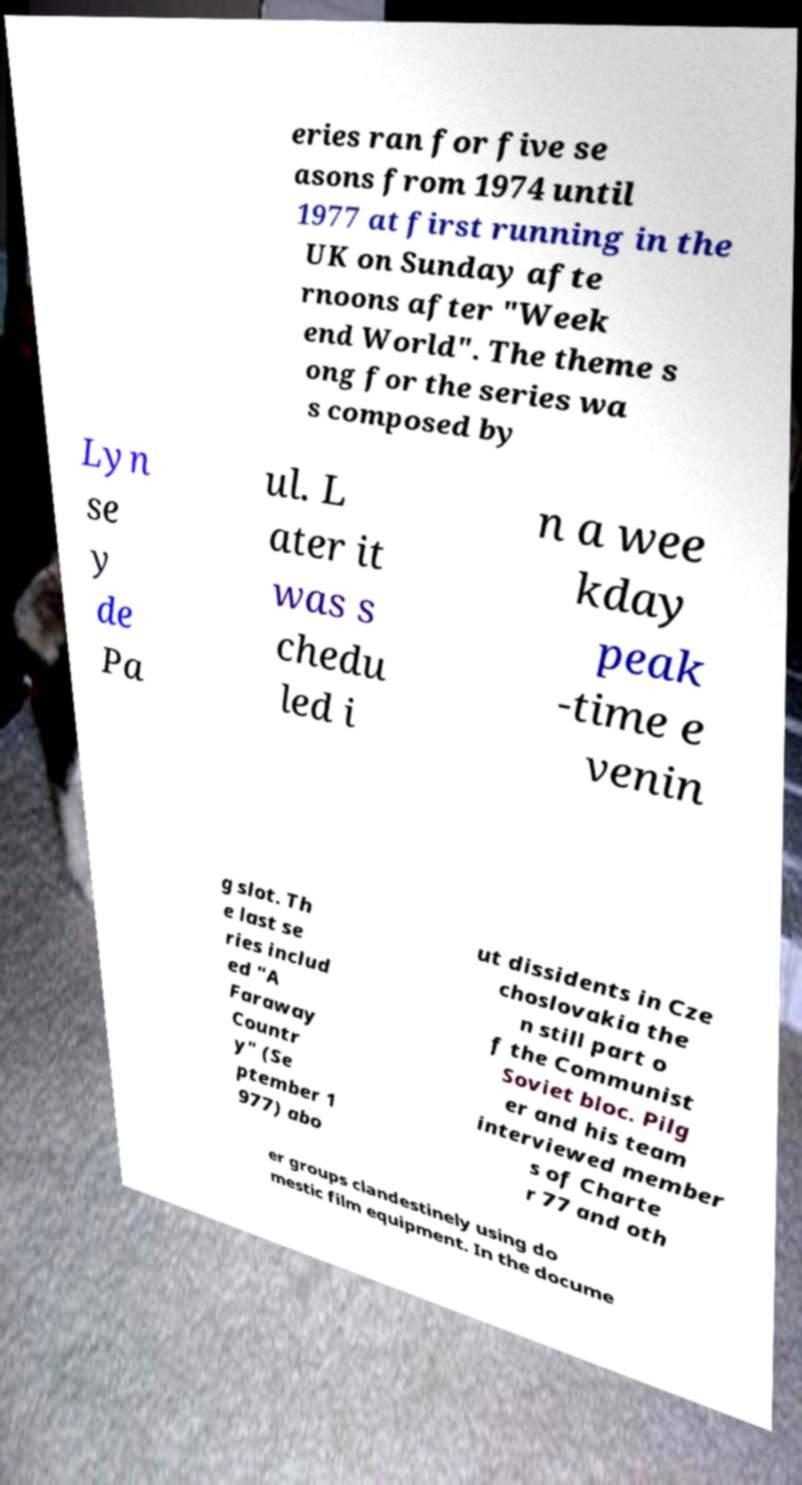What messages or text are displayed in this image? I need them in a readable, typed format. eries ran for five se asons from 1974 until 1977 at first running in the UK on Sunday afte rnoons after "Week end World". The theme s ong for the series wa s composed by Lyn se y de Pa ul. L ater it was s chedu led i n a wee kday peak -time e venin g slot. Th e last se ries includ ed "A Faraway Countr y" (Se ptember 1 977) abo ut dissidents in Cze choslovakia the n still part o f the Communist Soviet bloc. Pilg er and his team interviewed member s of Charte r 77 and oth er groups clandestinely using do mestic film equipment. In the docume 